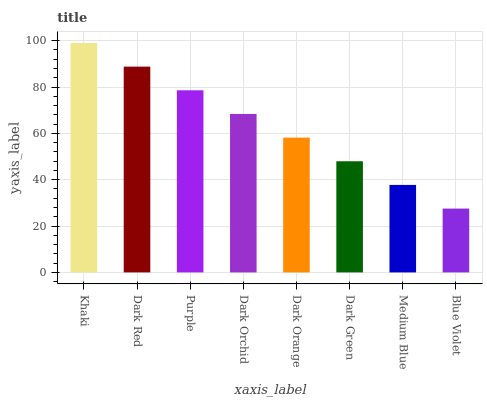Is Blue Violet the minimum?
Answer yes or no. Yes. Is Khaki the maximum?
Answer yes or no. Yes. Is Dark Red the minimum?
Answer yes or no. No. Is Dark Red the maximum?
Answer yes or no. No. Is Khaki greater than Dark Red?
Answer yes or no. Yes. Is Dark Red less than Khaki?
Answer yes or no. Yes. Is Dark Red greater than Khaki?
Answer yes or no. No. Is Khaki less than Dark Red?
Answer yes or no. No. Is Dark Orchid the high median?
Answer yes or no. Yes. Is Dark Orange the low median?
Answer yes or no. Yes. Is Khaki the high median?
Answer yes or no. No. Is Medium Blue the low median?
Answer yes or no. No. 